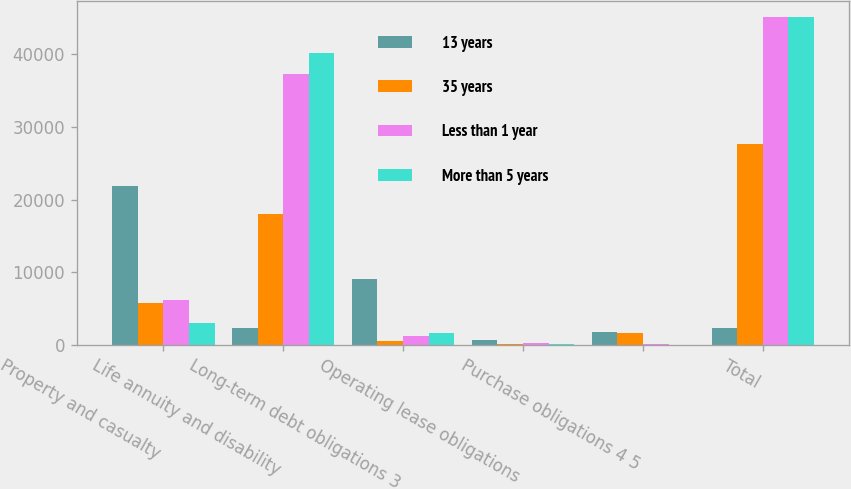<chart> <loc_0><loc_0><loc_500><loc_500><stacked_bar_chart><ecel><fcel>Property and casualty<fcel>Life annuity and disability<fcel>Long-term debt obligations 3<fcel>Operating lease obligations<fcel>Purchase obligations 4 5<fcel>Total<nl><fcel>13 years<fcel>21885<fcel>2390<fcel>9093<fcel>723<fcel>1764<fcel>2390<nl><fcel>35 years<fcel>5777<fcel>18037<fcel>536<fcel>175<fcel>1614<fcel>27729<nl><fcel>Less than 1 year<fcel>6150<fcel>37318<fcel>1288<fcel>285<fcel>120<fcel>45161<nl><fcel>More than 5 years<fcel>3016<fcel>40255<fcel>1613<fcel>162<fcel>14<fcel>45112<nl></chart> 